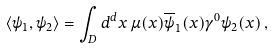<formula> <loc_0><loc_0><loc_500><loc_500>\left < \psi _ { 1 } , \psi _ { 2 } \right > = \int _ { D } d ^ { d } x \, \mu ( x ) \overline { \psi } _ { 1 } ( x ) \gamma ^ { 0 } \psi _ { 2 } ( x ) \, ,</formula> 